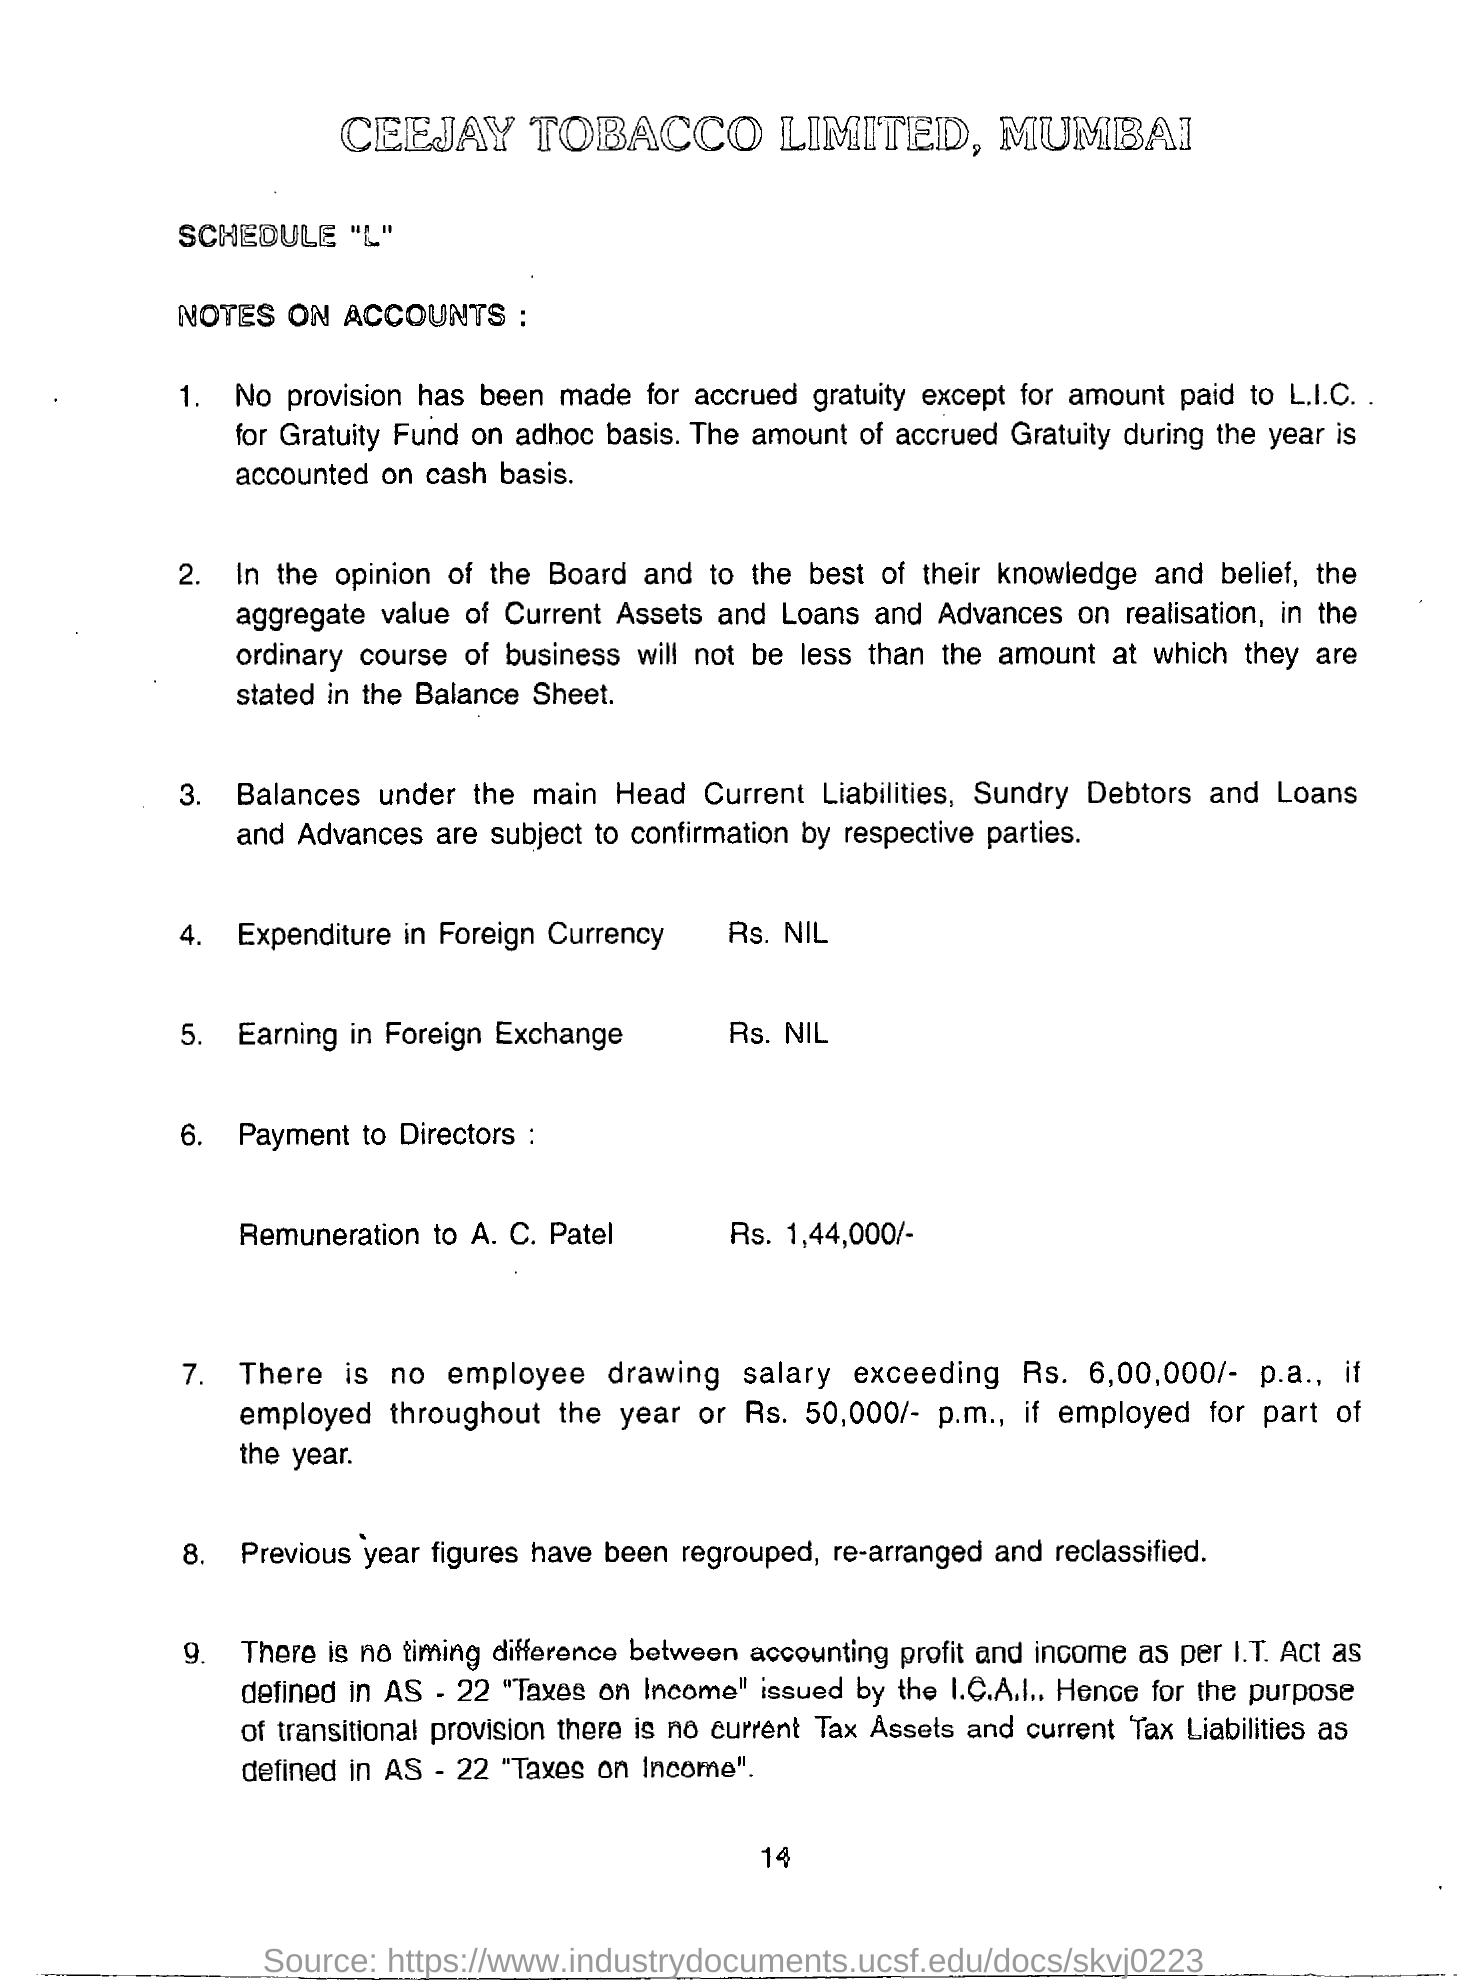What is the name of  company?
Give a very brief answer. CEEJAY TOBACCO LIMITED. Where is it located?
Offer a terse response. MUMBAI. How many Rs. were given to A. C. Patel as Remuneration?
Make the answer very short. Rs. 1,44,000/-. Who issued "TAXES ON INCOME"?
Keep it short and to the point. I.C.A.I. 